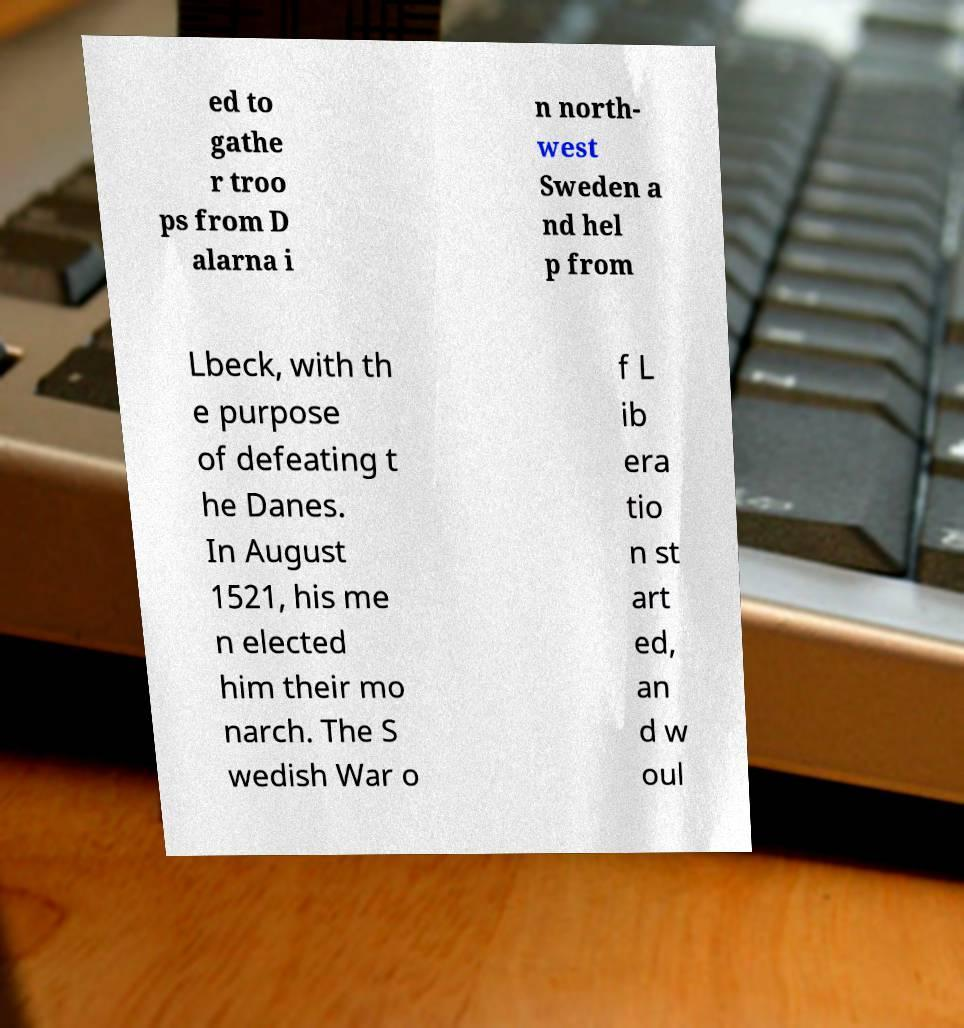I need the written content from this picture converted into text. Can you do that? ed to gathe r troo ps from D alarna i n north- west Sweden a nd hel p from Lbeck, with th e purpose of defeating t he Danes. In August 1521, his me n elected him their mo narch. The S wedish War o f L ib era tio n st art ed, an d w oul 